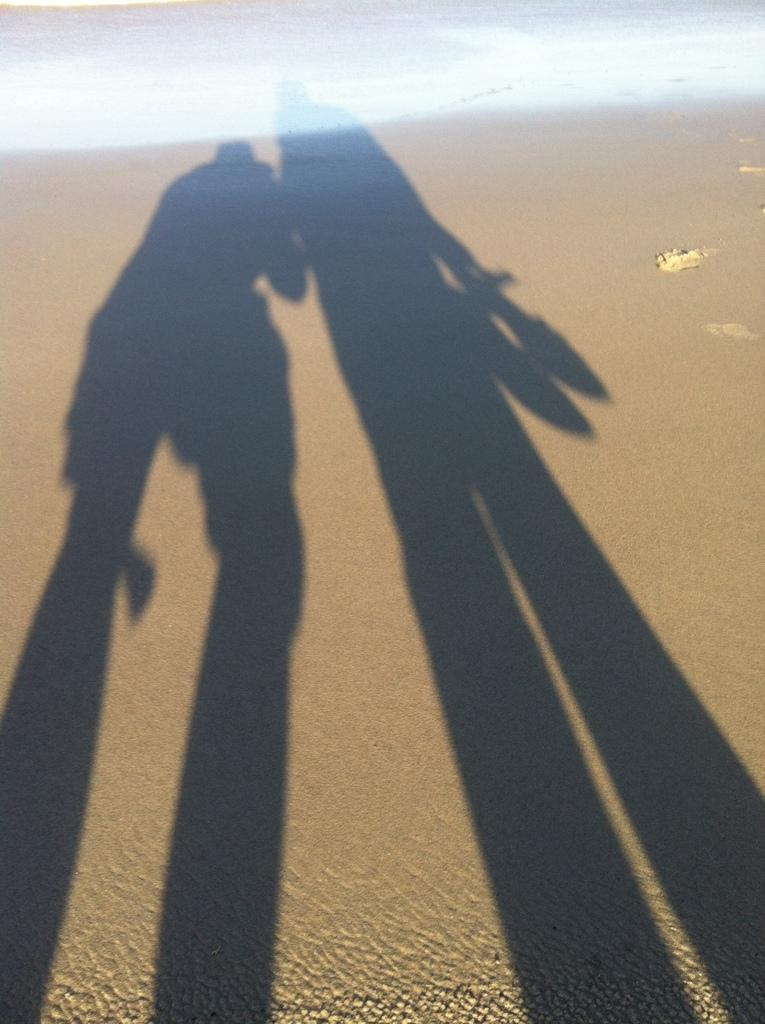What can be seen in the image that indicates the presence of people? There are shadows of people in the image. What type of terrain is visible in the image? There is sand visible in the image. What else is visible in the image besides sand? There is water visible in the image. What type of jewel is the dad wearing in the image? There is no dad or jewel present in the image. How much credit does the person in the image have on their account? There is no reference to credit or an account in the image. 